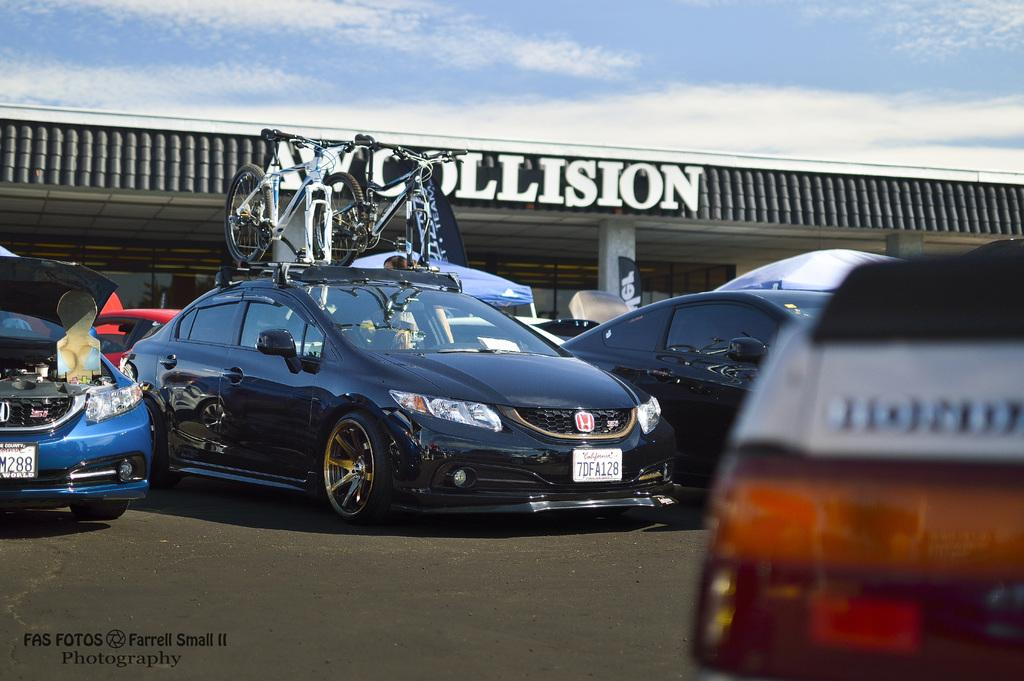<image>
Describe the image concisely. A Honda with bikes on the roof rack is under a sign that says AW Collision. 